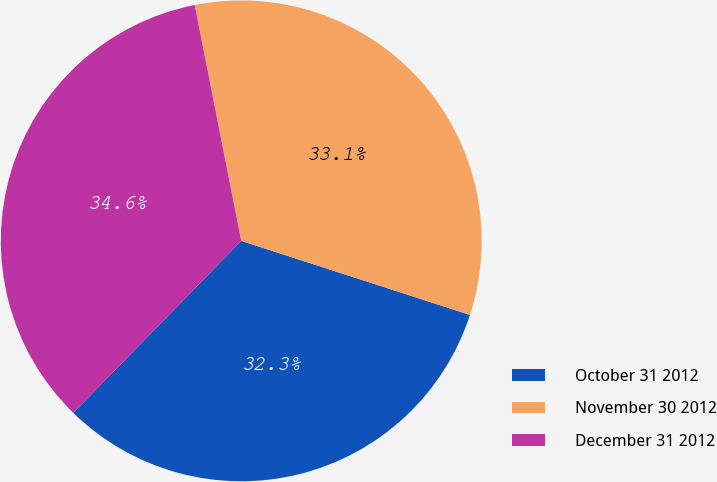Convert chart. <chart><loc_0><loc_0><loc_500><loc_500><pie_chart><fcel>October 31 2012<fcel>November 30 2012<fcel>December 31 2012<nl><fcel>32.33%<fcel>33.09%<fcel>34.59%<nl></chart> 